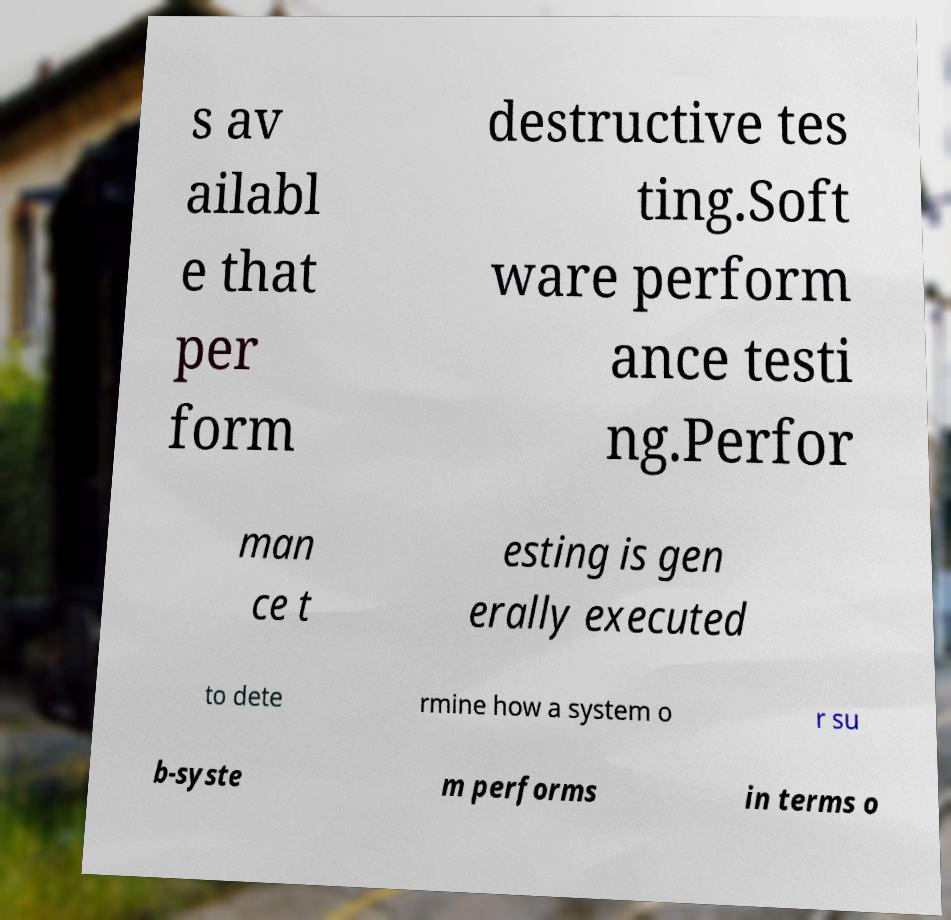What messages or text are displayed in this image? I need them in a readable, typed format. s av ailabl e that per form destructive tes ting.Soft ware perform ance testi ng.Perfor man ce t esting is gen erally executed to dete rmine how a system o r su b-syste m performs in terms o 